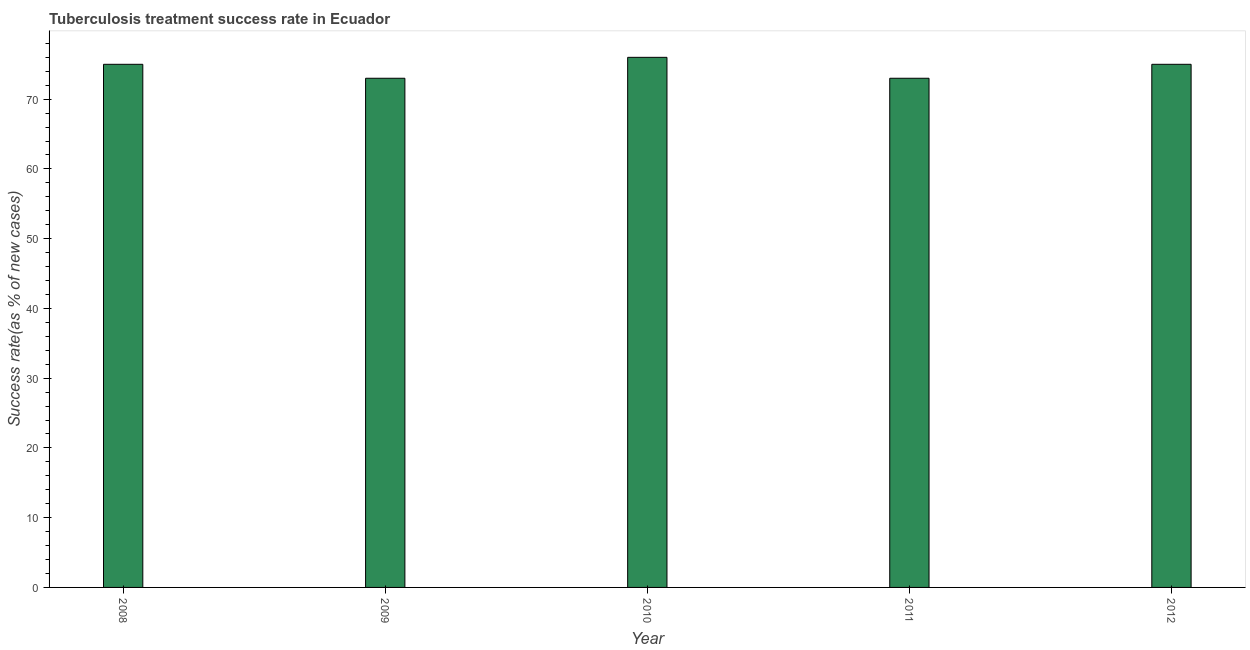Does the graph contain grids?
Make the answer very short. No. What is the title of the graph?
Your answer should be compact. Tuberculosis treatment success rate in Ecuador. What is the label or title of the Y-axis?
Offer a very short reply. Success rate(as % of new cases). What is the tuberculosis treatment success rate in 2011?
Give a very brief answer. 73. Across all years, what is the minimum tuberculosis treatment success rate?
Your answer should be very brief. 73. What is the sum of the tuberculosis treatment success rate?
Provide a short and direct response. 372. What is the average tuberculosis treatment success rate per year?
Offer a terse response. 74. What is the median tuberculosis treatment success rate?
Offer a very short reply. 75. In how many years, is the tuberculosis treatment success rate greater than 74 %?
Offer a terse response. 3. Do a majority of the years between 2008 and 2012 (inclusive) have tuberculosis treatment success rate greater than 52 %?
Give a very brief answer. Yes. Is the tuberculosis treatment success rate in 2009 less than that in 2011?
Your response must be concise. No. What is the difference between the highest and the second highest tuberculosis treatment success rate?
Provide a succinct answer. 1. Is the sum of the tuberculosis treatment success rate in 2009 and 2010 greater than the maximum tuberculosis treatment success rate across all years?
Your answer should be compact. Yes. How many bars are there?
Keep it short and to the point. 5. Are all the bars in the graph horizontal?
Your answer should be very brief. No. What is the Success rate(as % of new cases) in 2011?
Provide a short and direct response. 73. What is the Success rate(as % of new cases) of 2012?
Make the answer very short. 75. What is the difference between the Success rate(as % of new cases) in 2008 and 2009?
Your response must be concise. 2. What is the difference between the Success rate(as % of new cases) in 2008 and 2011?
Your response must be concise. 2. What is the difference between the Success rate(as % of new cases) in 2008 and 2012?
Your answer should be very brief. 0. What is the difference between the Success rate(as % of new cases) in 2009 and 2011?
Ensure brevity in your answer.  0. What is the difference between the Success rate(as % of new cases) in 2009 and 2012?
Make the answer very short. -2. What is the difference between the Success rate(as % of new cases) in 2011 and 2012?
Ensure brevity in your answer.  -2. What is the ratio of the Success rate(as % of new cases) in 2008 to that in 2010?
Keep it short and to the point. 0.99. What is the ratio of the Success rate(as % of new cases) in 2008 to that in 2011?
Provide a succinct answer. 1.03. What is the ratio of the Success rate(as % of new cases) in 2009 to that in 2011?
Keep it short and to the point. 1. What is the ratio of the Success rate(as % of new cases) in 2009 to that in 2012?
Offer a very short reply. 0.97. What is the ratio of the Success rate(as % of new cases) in 2010 to that in 2011?
Make the answer very short. 1.04. What is the ratio of the Success rate(as % of new cases) in 2010 to that in 2012?
Provide a short and direct response. 1.01. What is the ratio of the Success rate(as % of new cases) in 2011 to that in 2012?
Your response must be concise. 0.97. 